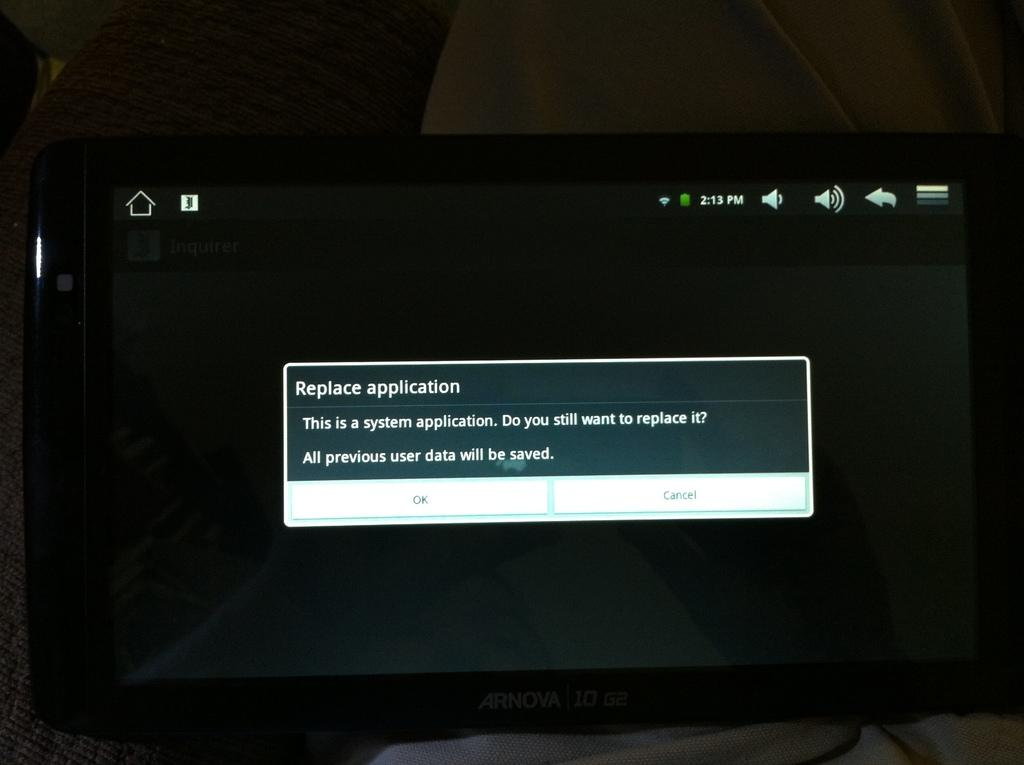<image>
Offer a succinct explanation of the picture presented. An Ornova computer monitor with the message "Replace application" 